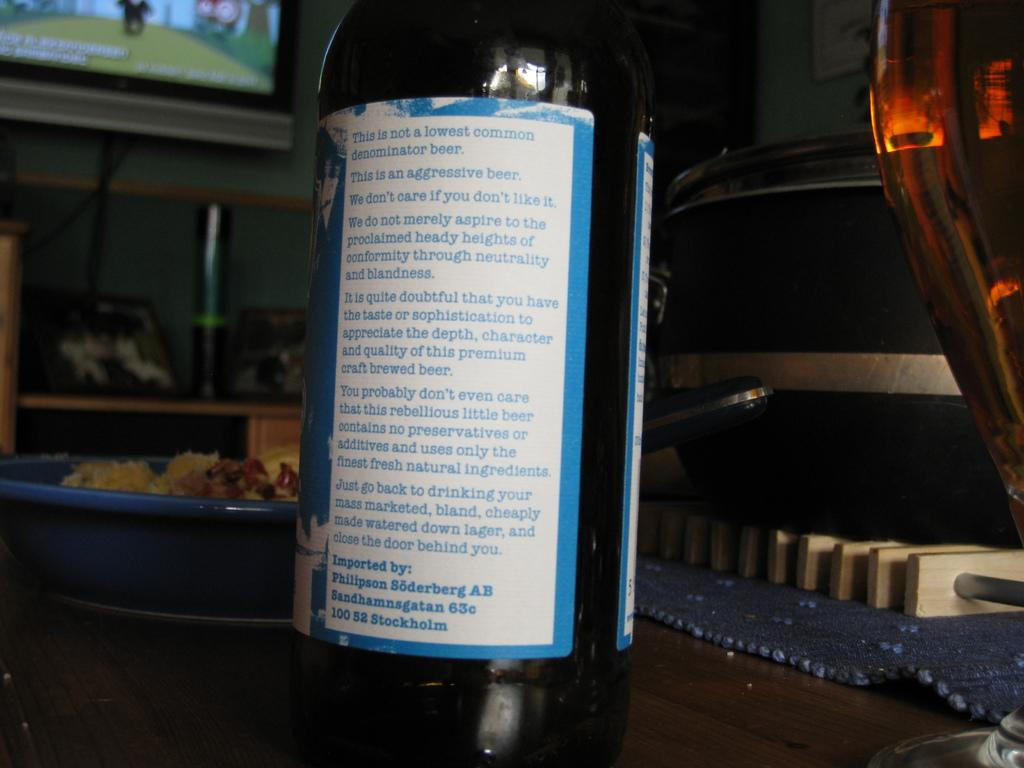<image>
Relay a brief, clear account of the picture shown. A bottle of craft beer with a blue and white label that has been imported by Philipson Soderberg AB 